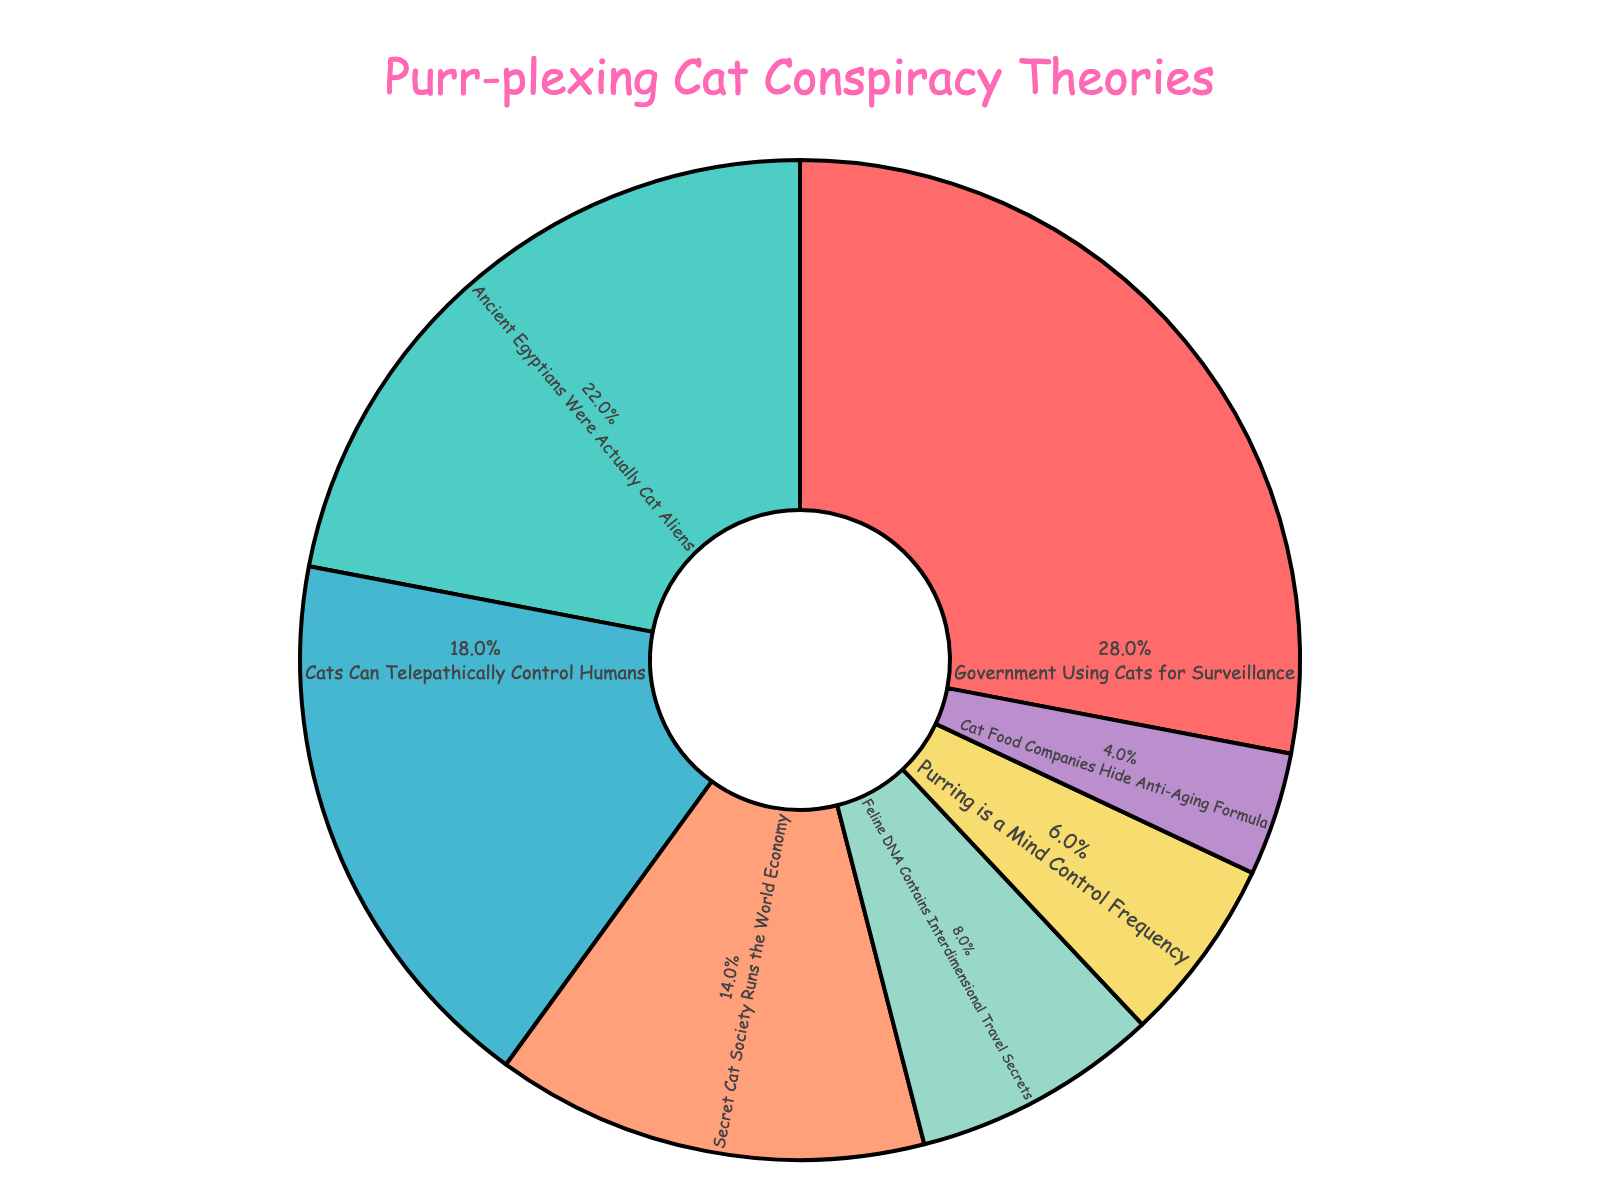What's the most popular cat-related conspiracy theory? Look at the pie chart and identify the slice with the largest percentage. The theme "Government Using Cats for Surveillance" has the highest percentage (28%).
Answer: Government Using Cats for Surveillance What percentage of conspiracy theories involve the idea that cats control humans telepathically or through purring? Sum the percentages of "Cats Can Telepathically Control Humans" and "Purring is a Mind Control Frequency" themes. The sum is 18% + 6% = 24%.
Answer: 24% Which theme has a lower percentage: "Secret Cat Society Runs the World Economy" or "Ancient Egyptians Were Actually Cat Aliens"? Compare the percentages of the two themes. The theme "Secret Cat Society Runs the World Economy" has 14%, and "Ancient Egyptians Were Actually Cat Aliens" has 22%. Thus, the former has a lower percentage.
Answer: Secret Cat Society Runs the World Economy How much more popular is the "Government Using Cats for Surveillance" theme compared to the "Feline DNA Contains Interdimensional Travel Secrets" theme? Subtract the percentage of the "Feline DNA Contains Interdimensional Travel Secrets" theme from the percentage of the "Government Using Cats for Surveillance" theme. That is, 28% - 8% = 20%.
Answer: 20% Is the percentage of the "Cat Food Companies Hide Anti-Aging Formula" theme less than half of the "Secret Cat Society Runs the World Economy" theme? Divide the percentage of the "Secret Cat Society Runs the World Economy" theme by 2 and compare it with the percentage of the "Cat Food Companies Hide Anti-Aging Formula" theme. Half of 14% is 7%, which is greater than 4%. So, yes, it is.
Answer: Yes What is the combined percentage of theories related to ancient and interdimensional themes? Sum the percentages of the "Ancient Egyptians Were Actually Cat Aliens" and "Feline DNA Contains Interdimensional Travel Secrets" themes. The sum is 22% + 8% = 30%.
Answer: 30% Which theme, according to the pie chart, is represented by the green color? Identify the green color in the legend of the pie chart. The green slice corresponds to the theme "Ancient Egyptians Were Actually Cat Aliens."
Answer: Ancient Egyptians Were Actually Cat Aliens Are there more theories about cats controlling humans telepathically than theories about a secret cat society running the world economy? Compare the percentages of the "Cats Can Telepathically Control Humans" theme and the "Secret Cat Society Runs the World Economy" theme. The percentages are 18% and 14%, respectively.
Answer: Yes What is the difference in percentage between the least and the most popular conspiracy theories? Subtract the percentage of the least popular theme from that of the most popular theme. The least popular theme is "Cat Food Companies Hide Anti-Aging Formula" at 4%, and the most popular is "Government Using Cats for Surveillance" at 28%. Thus, 28% - 4% = 24%.
Answer: 24% 